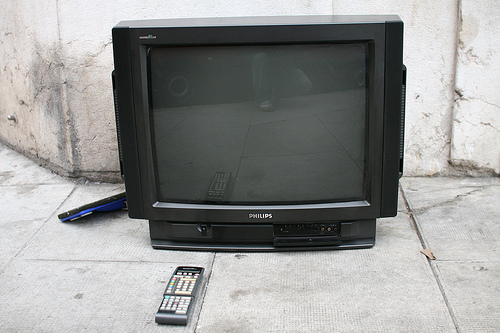<image>
Is the tv behind the remote? Yes. From this viewpoint, the tv is positioned behind the remote, with the remote partially or fully occluding the tv. Where is the tv in relation to the remote? Is it above the remote? No. The tv is not positioned above the remote. The vertical arrangement shows a different relationship. 